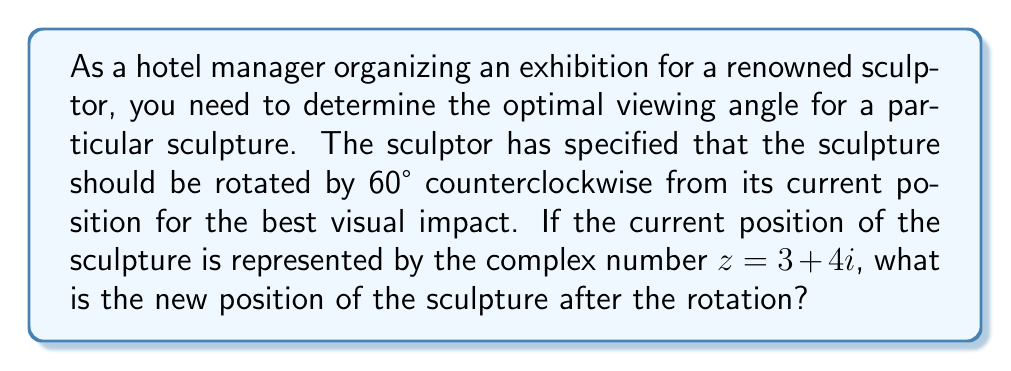What is the answer to this math problem? To solve this problem, we'll use the properties of complex number rotations:

1) A rotation of $\theta$ radians counterclockwise around the origin can be achieved by multiplying the complex number by $e^{i\theta}$.

2) We need to convert 60° to radians: $60° = \frac{\pi}{3}$ radians.

3) Therefore, we need to multiply $z$ by $e^{i\frac{\pi}{3}}$.

4) $e^{i\frac{\pi}{3}} = \cos(\frac{\pi}{3}) + i\sin(\frac{\pi}{3}) = \frac{1}{2} + i\frac{\sqrt{3}}{2}$

5) Now, we multiply $z$ by this rotation factor:

   $$(3 + 4i)(\frac{1}{2} + i\frac{\sqrt{3}}{2})$$

6) Expanding this:
   
   $$3(\frac{1}{2} + i\frac{\sqrt{3}}{2}) + 4i(\frac{1}{2} + i\frac{\sqrt{3}}{2})$$
   
   $$= \frac{3}{2} + i\frac{3\sqrt{3}}{2} + 2i + i^2\frac{4\sqrt{3}}{2}$$
   
   $$= \frac{3}{2} + i\frac{3\sqrt{3}}{2} + 2i - \frac{4\sqrt{3}}{2}$$
   
   $$= (\frac{3}{2} - \frac{4\sqrt{3}}{2}) + i(\frac{3\sqrt{3}}{2} + 2)$$

7) Simplifying:
   
   $$= -\frac{\sqrt{3}}{2} + i(\frac{3\sqrt{3}}{2} + 2)$$

This is the new position of the sculpture after rotation.
Answer: The new position of the sculpture after rotation is $-\frac{\sqrt{3}}{2} + i(\frac{3\sqrt{3}}{2} + 2)$. 